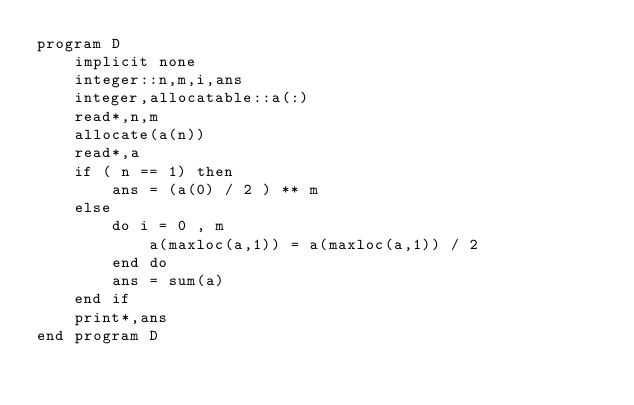Convert code to text. <code><loc_0><loc_0><loc_500><loc_500><_FORTRAN_>program D
    implicit none
    integer::n,m,i,ans
    integer,allocatable::a(:)
    read*,n,m
    allocate(a(n))
    read*,a
    if ( n == 1) then
        ans = (a(0) / 2 ) ** m
    else
        do i = 0 , m
            a(maxloc(a,1)) = a(maxloc(a,1)) / 2 
        end do
        ans = sum(a)
    end if
    print*,ans
end program D</code> 